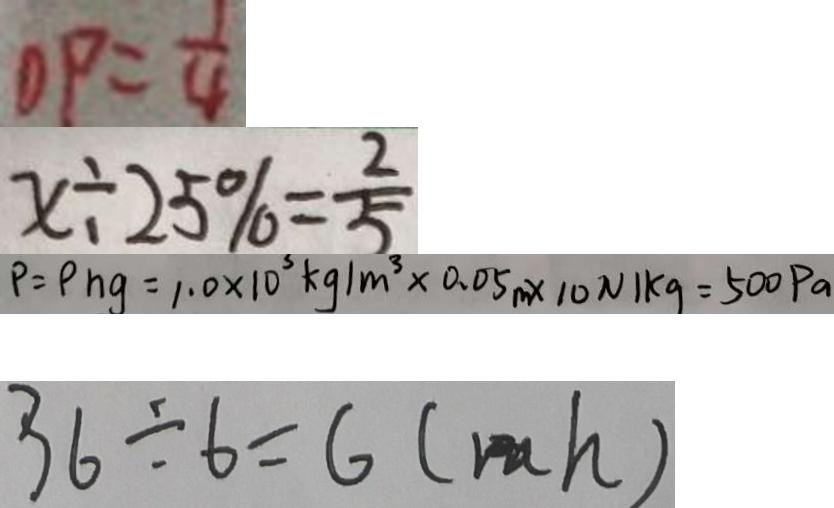Convert formula to latex. <formula><loc_0><loc_0><loc_500><loc_500>O P = \frac { 1 } { 4 } 
 x \div 2 5 \% = \frac { 2 } { 5 } 
 P = P h g = 1 . 0 \times 1 0 ^ { 3 } k g / m ^ { 3 } \times 0 . 0 5 m \times 1 0 N k g = 5 0 0 P a 
 3 6 \div 6 = 6 ( m h )</formula> 